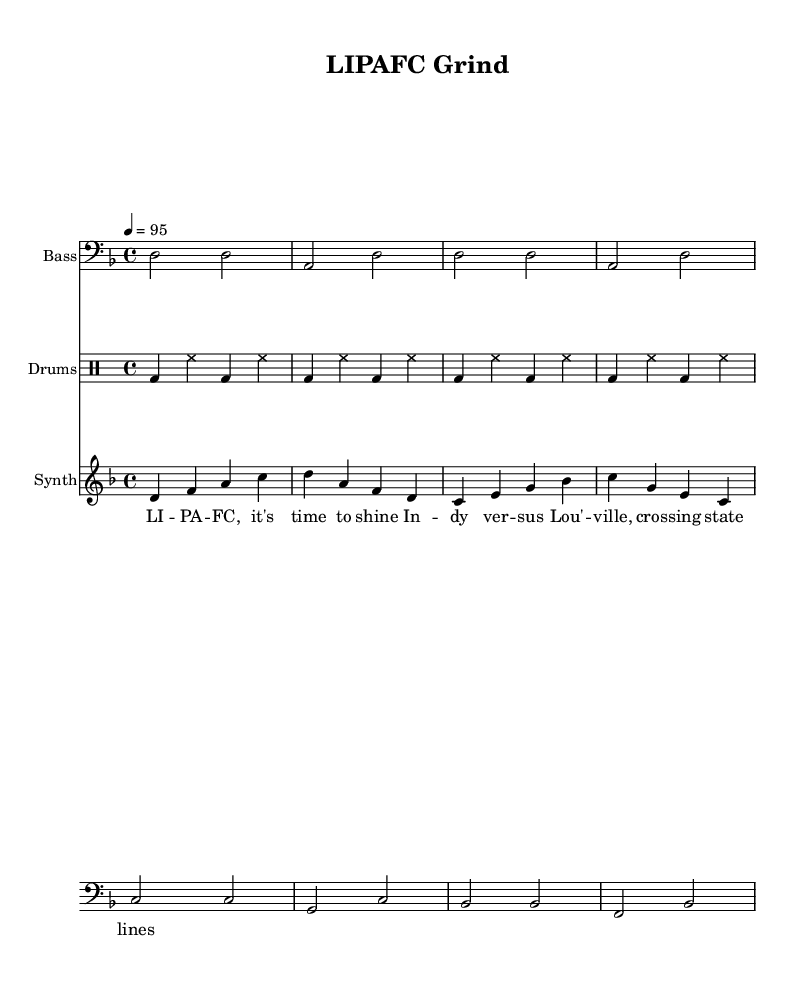What is the key signature of this music? The key signature is D minor, which is indicated by the presence of one flat (B flat) in the key signature.
Answer: D minor What is the time signature of this music? The time signature is 4/4, shown at the beginning of the piece. This means there are four beats in each measure, and each quarter note gets one beat.
Answer: 4/4 What is the tempo of the piece? The tempo marking indicates a speed of quarter note equals 95 beats per minute, which provides a moderate pace suitable for warm-ups.
Answer: 95 How many measures are in the bass line? Counting the separate groupings within the bass line, there are a total of eight measures.
Answer: 8 What type of music is this? This piece is categorized as Hip Hop, evident from the rhythmic patterns, lyrics, and the overall style intended for motivational pre-game warmups and workouts.
Answer: Hip Hop What is the emotional tone of the lyrics? The lyrics convey a motivational and triumphant spirit, emphasizing the desire to shine and cross boundaries, reflecting the essence of competition and ambition.
Answer: Motivational How does the drum pattern contribute to the song's rhythm? The drum pattern features a consistent kick and hi-hat interaction that drives the rhythm forward, providing a strong foundation essential for energizing workouts and games.
Answer: Drives rhythm 